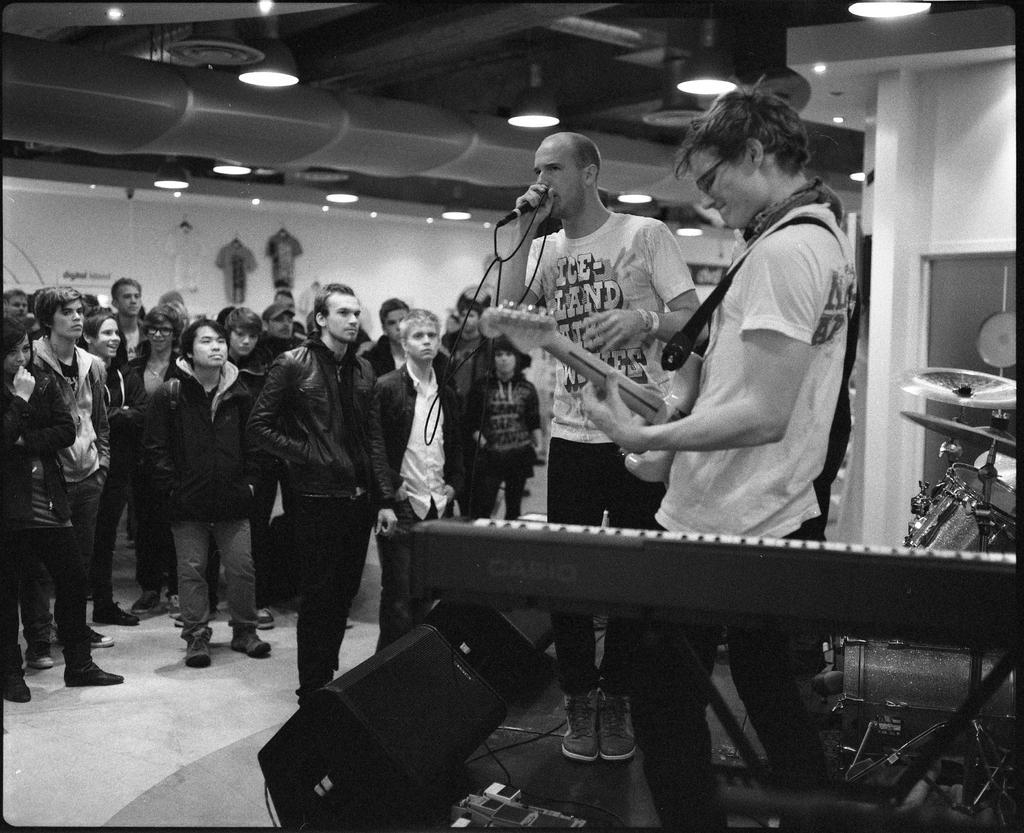How would you summarize this image in a sentence or two? In this picture there are two people at the center of the image on the stage, they are singing and there is a piano at the right side of the image and speakers on the stage, there are group of people at the left side of the image as the audience. 